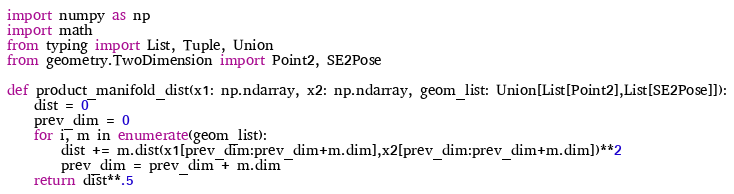Convert code to text. <code><loc_0><loc_0><loc_500><loc_500><_Python_>import numpy as np
import math
from typing import List, Tuple, Union
from geometry.TwoDimension import Point2, SE2Pose

def product_manifold_dist(x1: np.ndarray, x2: np.ndarray, geom_list: Union[List[Point2],List[SE2Pose]]):
    dist = 0
    prev_dim = 0
    for i, m in enumerate(geom_list):
        dist += m.dist(x1[prev_dim:prev_dim+m.dim],x2[prev_dim:prev_dim+m.dim])**2
        prev_dim = prev_dim + m.dim
    return dist**.5</code> 